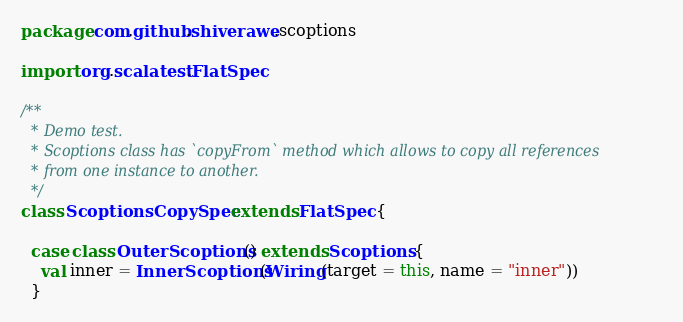Convert code to text. <code><loc_0><loc_0><loc_500><loc_500><_Scala_>package com.github.shiverawe.scoptions

import org.scalatest.FlatSpec

/**
  * Demo test.
  * Scoptions class has `copyFrom` method which allows to copy all references
  * from one instance to another.
  */
class ScoptionsCopySpec extends FlatSpec {

  case class OuterScoptions() extends Scoptions {
    val inner = InnerScoptions(Wiring(target = this, name = "inner"))
  }
</code> 